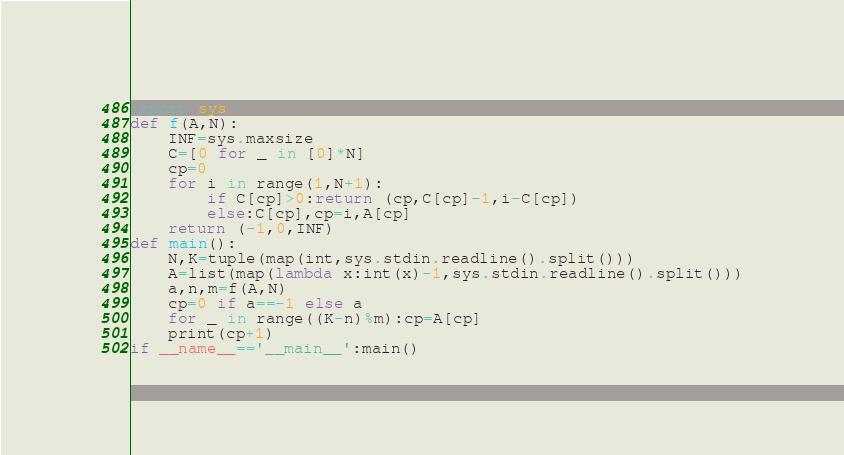<code> <loc_0><loc_0><loc_500><loc_500><_Python_>import sys
def f(A,N):
    INF=sys.maxsize
    C=[0 for _ in [0]*N]
    cp=0
    for i in range(1,N+1):
        if C[cp]>0:return (cp,C[cp]-1,i-C[cp])
        else:C[cp],cp=i,A[cp]
    return (-1,0,INF)
def main():
    N,K=tuple(map(int,sys.stdin.readline().split()))
    A=list(map(lambda x:int(x)-1,sys.stdin.readline().split()))
    a,n,m=f(A,N)
    cp=0 if a==-1 else a
    for _ in range((K-n)%m):cp=A[cp]
    print(cp+1)
if __name__=='__main__':main()</code> 